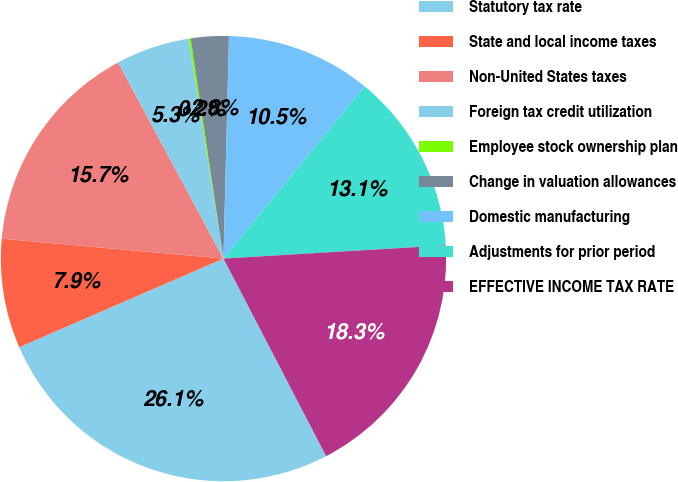Convert chart to OTSL. <chart><loc_0><loc_0><loc_500><loc_500><pie_chart><fcel>Statutory tax rate<fcel>State and local income taxes<fcel>Non-United States taxes<fcel>Foreign tax credit utilization<fcel>Employee stock ownership plan<fcel>Change in valuation allowances<fcel>Domestic manufacturing<fcel>Adjustments for prior period<fcel>EFFECTIVE INCOME TAX RATE<nl><fcel>26.11%<fcel>7.94%<fcel>15.73%<fcel>5.34%<fcel>0.15%<fcel>2.75%<fcel>10.53%<fcel>13.13%<fcel>18.32%<nl></chart> 